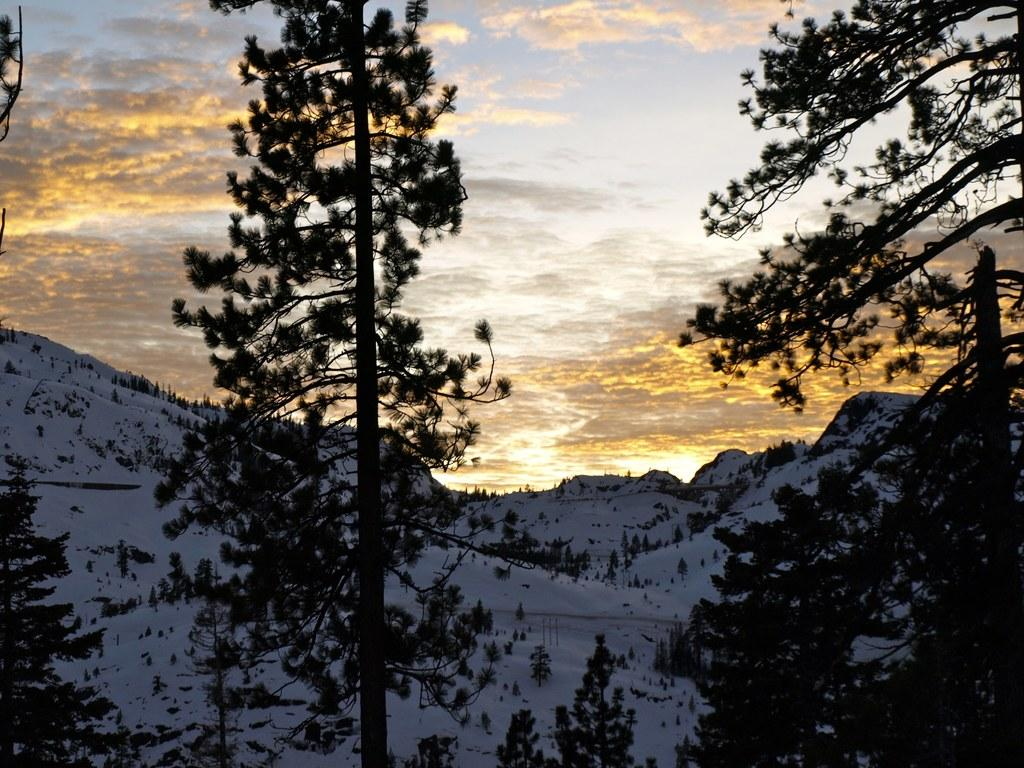What can be seen in the background of the image? The sky is visible in the image. What is the condition of the sky in the image? Clouds are present in the sky. What type of vegetation is visible in the image? There are trees in the image. What type of landscape feature can be seen in the image? Hills are visible in the image. What type of door can be seen in the image? There is no door present in the image. What substance is being used to create the clouds in the image? The clouds in the image are natural formations and do not involve any substances being used. 